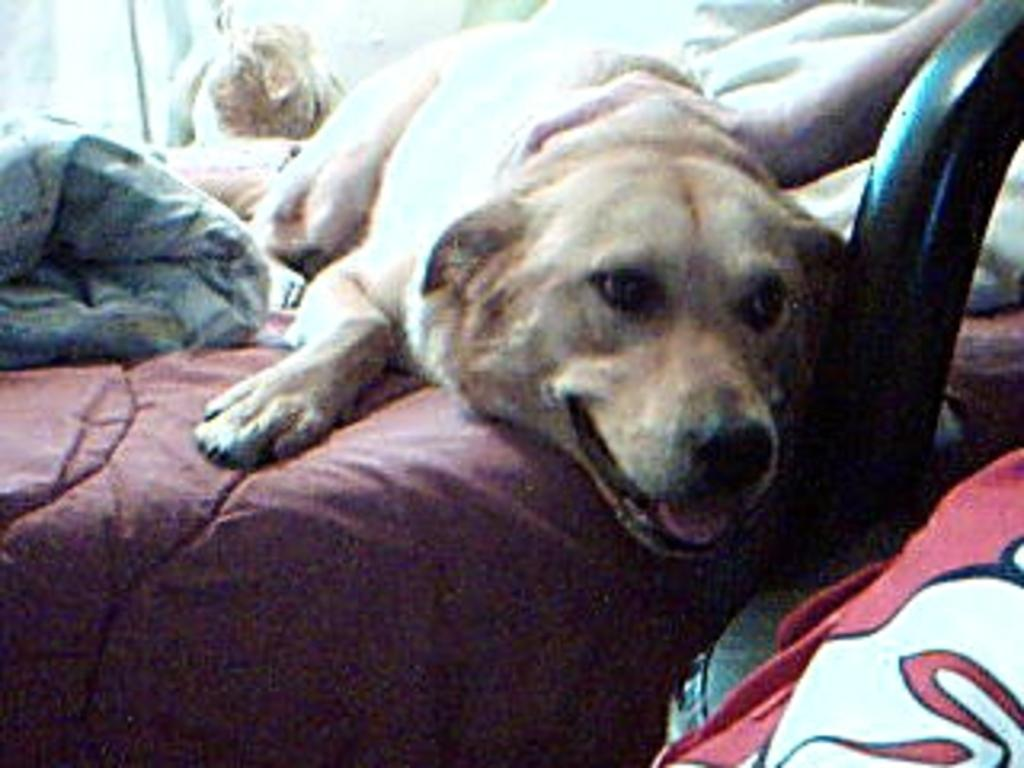What type of animal is in the image? There is a dog in the image. Where is the dog located? The dog is laying on the bed. What color is the dog? The dog is cream-colored. What is covering part of the bed? There is a blanket on the bed. What piece of furniture can be seen on the right side of the image? There is a chair on the right side of the image. What type of brush is the dog using to clean the bedroom in the image? There is no brush present in the image, and the dog is not cleaning the bedroom. 